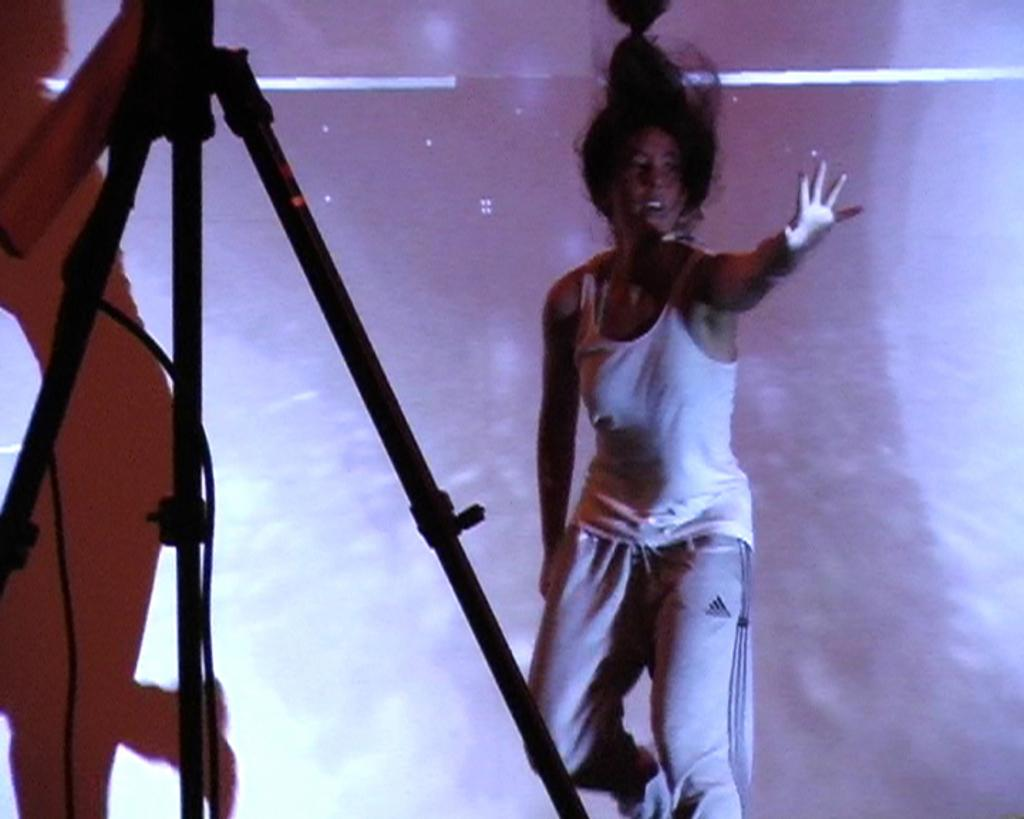Who is present in the image? There is a woman in the image. What is the woman wearing? The woman is wearing a white t-shirt. What color can be seen in the background of the image? There is a pink color in the background of the image. What can be seen on the left side of the image? There is a stand on the left side of the image. Can you describe any additional features in the image? There is a shadow of a person in the image. What grade does the tin receive in the image? There is no tin present in the image, and therefore no grade can be assigned. What language is spoken by the woman in the image? The image does not provide any information about the language spoken by the woman. 